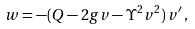Convert formula to latex. <formula><loc_0><loc_0><loc_500><loc_500>w = - ( Q - 2 g v - \Upsilon ^ { 2 } v ^ { 2 } ) \, v ^ { \prime } \, ,</formula> 